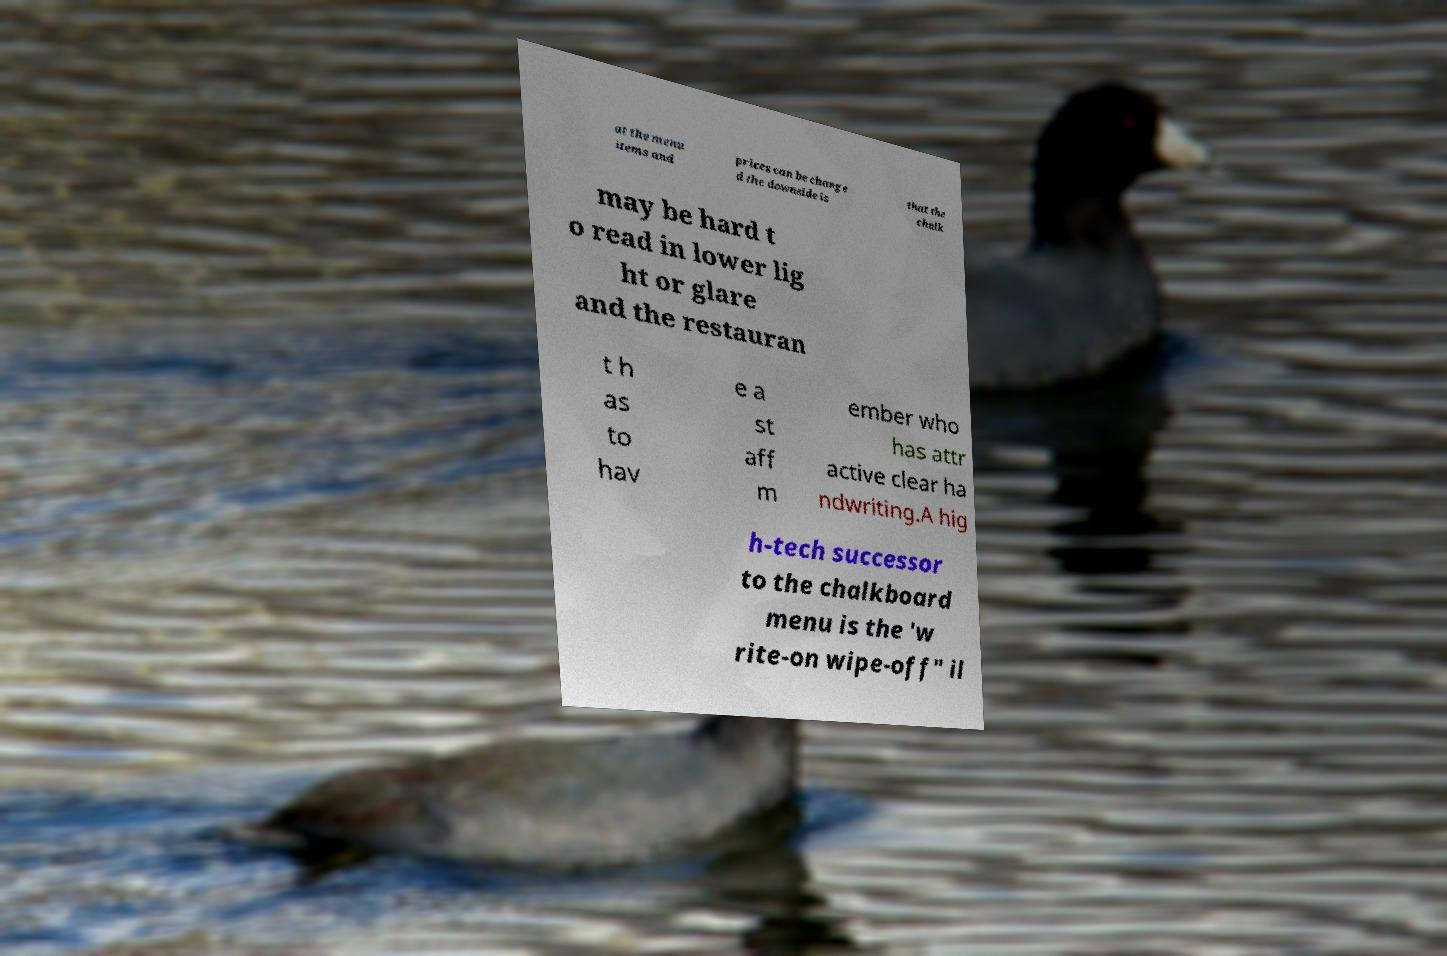For documentation purposes, I need the text within this image transcribed. Could you provide that? at the menu items and prices can be change d the downside is that the chalk may be hard t o read in lower lig ht or glare and the restauran t h as to hav e a st aff m ember who has attr active clear ha ndwriting.A hig h-tech successor to the chalkboard menu is the 'w rite-on wipe-off" il 